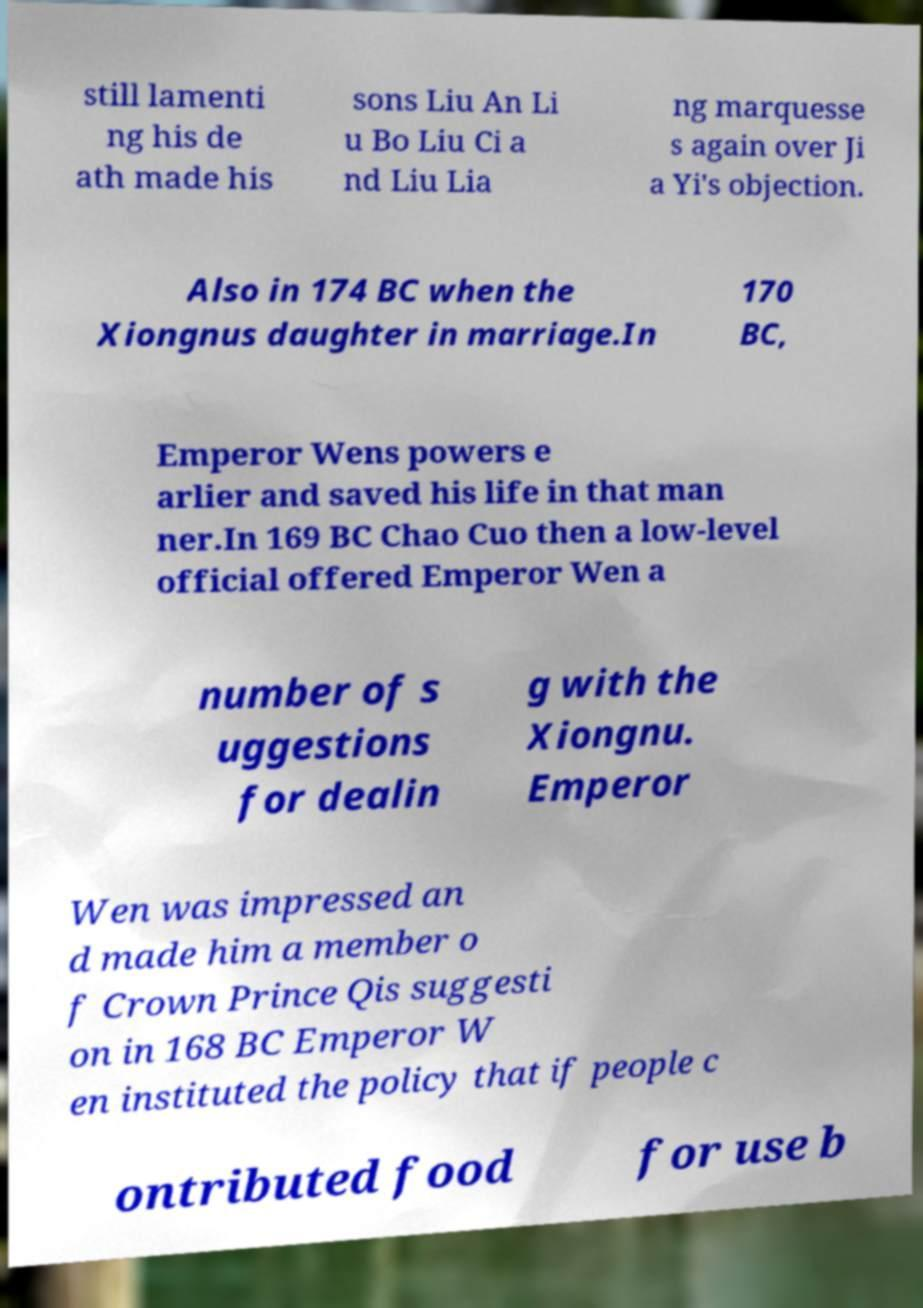I need the written content from this picture converted into text. Can you do that? still lamenti ng his de ath made his sons Liu An Li u Bo Liu Ci a nd Liu Lia ng marquesse s again over Ji a Yi's objection. Also in 174 BC when the Xiongnus daughter in marriage.In 170 BC, Emperor Wens powers e arlier and saved his life in that man ner.In 169 BC Chao Cuo then a low-level official offered Emperor Wen a number of s uggestions for dealin g with the Xiongnu. Emperor Wen was impressed an d made him a member o f Crown Prince Qis suggesti on in 168 BC Emperor W en instituted the policy that if people c ontributed food for use b 